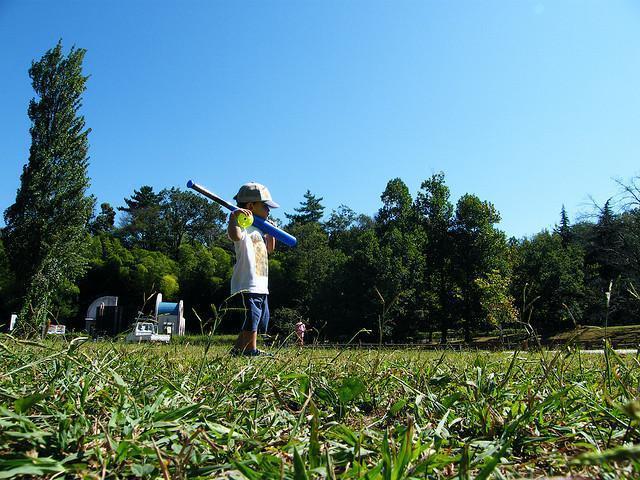How many cars are to the right?
Give a very brief answer. 0. 